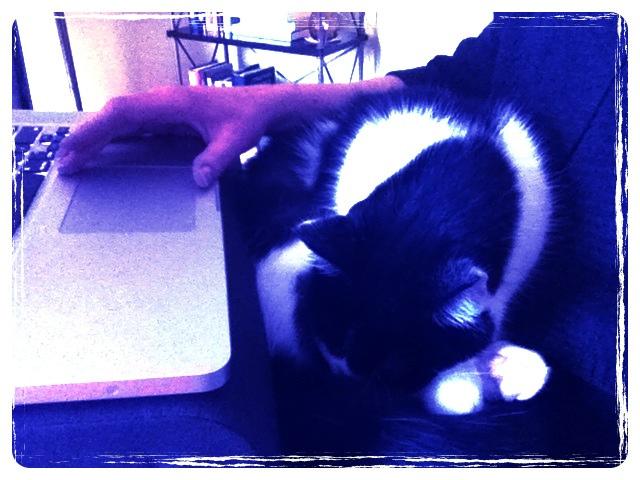What color is the cat's right paw?
Be succinct. White. What is on the keyboard?
Keep it brief. Hand. Does this fit the definition of a laptop?
Concise answer only. Yes. 